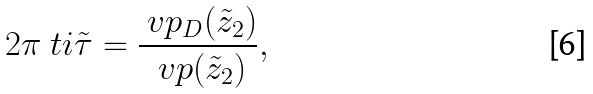<formula> <loc_0><loc_0><loc_500><loc_500>2 \pi \ t i \tilde { \tau } = \frac { \ v p _ { D } ( \tilde { z } _ { 2 } ) } { \ v p ( \tilde { z } _ { 2 } ) } ,</formula> 